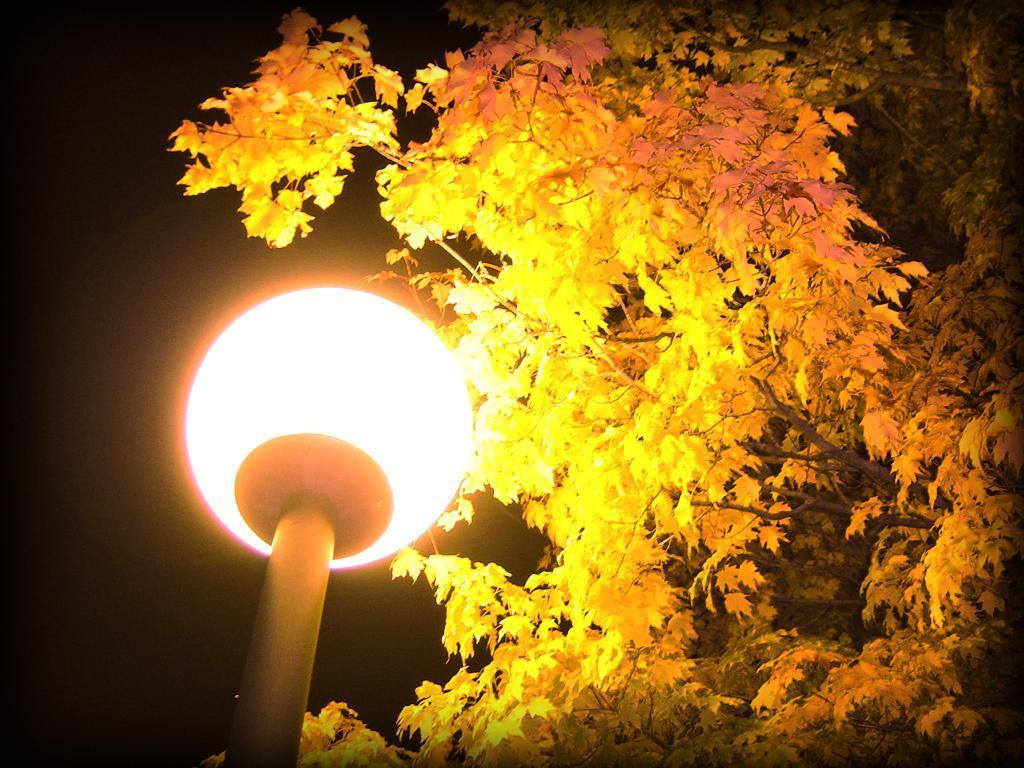In one or two sentences, can you explain what this image depicts? In this image we can see street light and tree. 